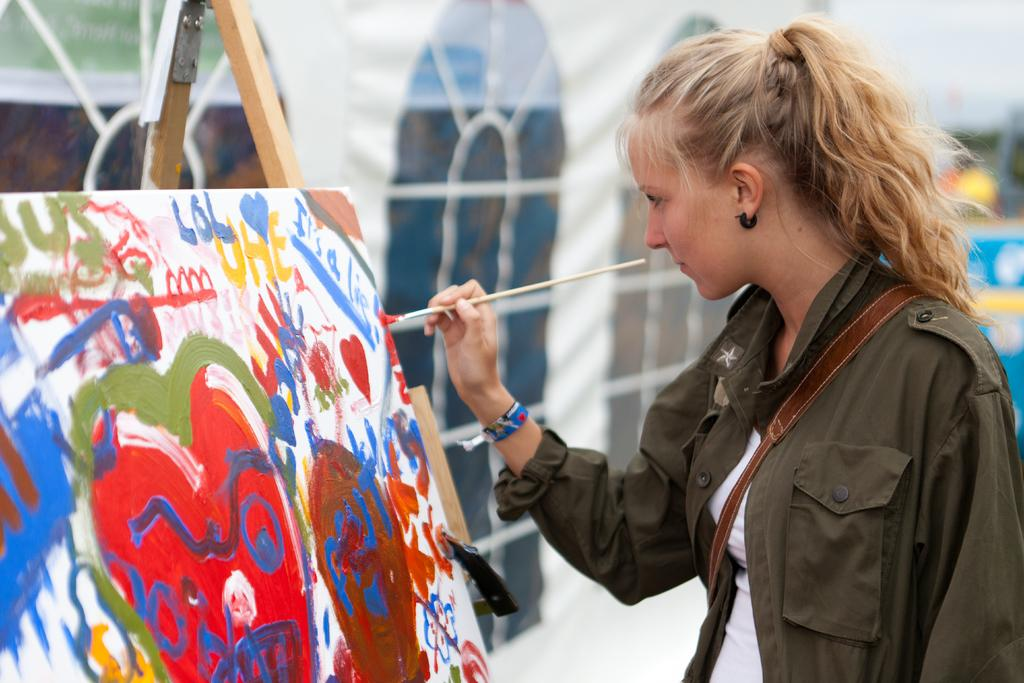What can be seen in the image? There is a person in the image. What is the person wearing? The person is wearing a brown jacket. What is the person carrying? The person is carrying a bag. What is the person holding? The person is holding a paintbrush. What is on the left side of the image? There is a painting on the left side of the image. What type of mailbox is present in the image? There is no mailbox present in the image. What selection of colors can be seen in the painting? The provided facts do not mention any colors in the painting, so we cannot determine the selection of colors. 